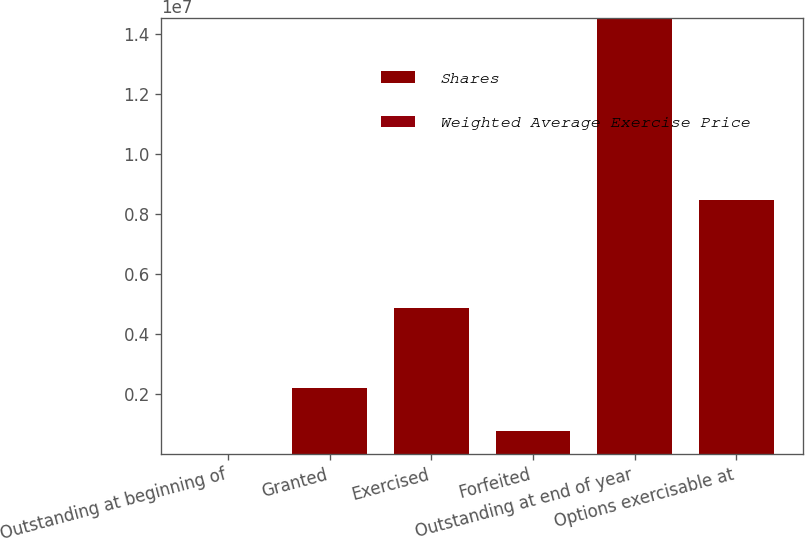Convert chart. <chart><loc_0><loc_0><loc_500><loc_500><stacked_bar_chart><ecel><fcel>Outstanding at beginning of<fcel>Granted<fcel>Exercised<fcel>Forfeited<fcel>Outstanding at end of year<fcel>Options exercisable at<nl><fcel>Shares<fcel>51.62<fcel>2.19163e+06<fcel>4.87512e+06<fcel>773145<fcel>1.45404e+07<fcel>8.45336e+06<nl><fcel>Weighted Average Exercise Price<fcel>42.21<fcel>51.62<fcel>38.3<fcel>43.9<fcel>44.86<fcel>46.95<nl></chart> 